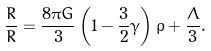<formula> <loc_0><loc_0><loc_500><loc_500>\frac { \ddot { R } } { R } = \frac { 8 \pi G } { 3 } \left ( 1 - \frac { 3 } { 2 } \gamma \right ) \rho + \frac { \Lambda } { 3 } .</formula> 